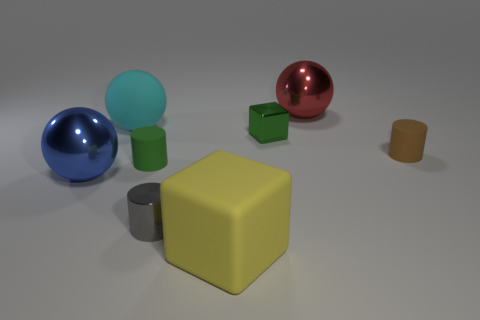How many tiny yellow rubber objects are the same shape as the gray metallic thing?
Your answer should be compact. 0. What number of large objects are rubber cubes or blue rubber cylinders?
Give a very brief answer. 1. Is the color of the big sphere that is in front of the brown matte thing the same as the large cube?
Offer a terse response. No. Is the color of the small cylinder that is right of the yellow object the same as the big ball that is on the left side of the large cyan sphere?
Keep it short and to the point. No. Is there a cyan ball that has the same material as the small green cylinder?
Provide a succinct answer. Yes. How many yellow objects are cubes or small shiny blocks?
Your answer should be compact. 1. Are there more cubes in front of the brown cylinder than big green rubber things?
Provide a succinct answer. Yes. Is the brown object the same size as the matte cube?
Keep it short and to the point. No. The small cylinder that is made of the same material as the tiny cube is what color?
Keep it short and to the point. Gray. The tiny rubber object that is the same color as the small cube is what shape?
Your answer should be compact. Cylinder. 